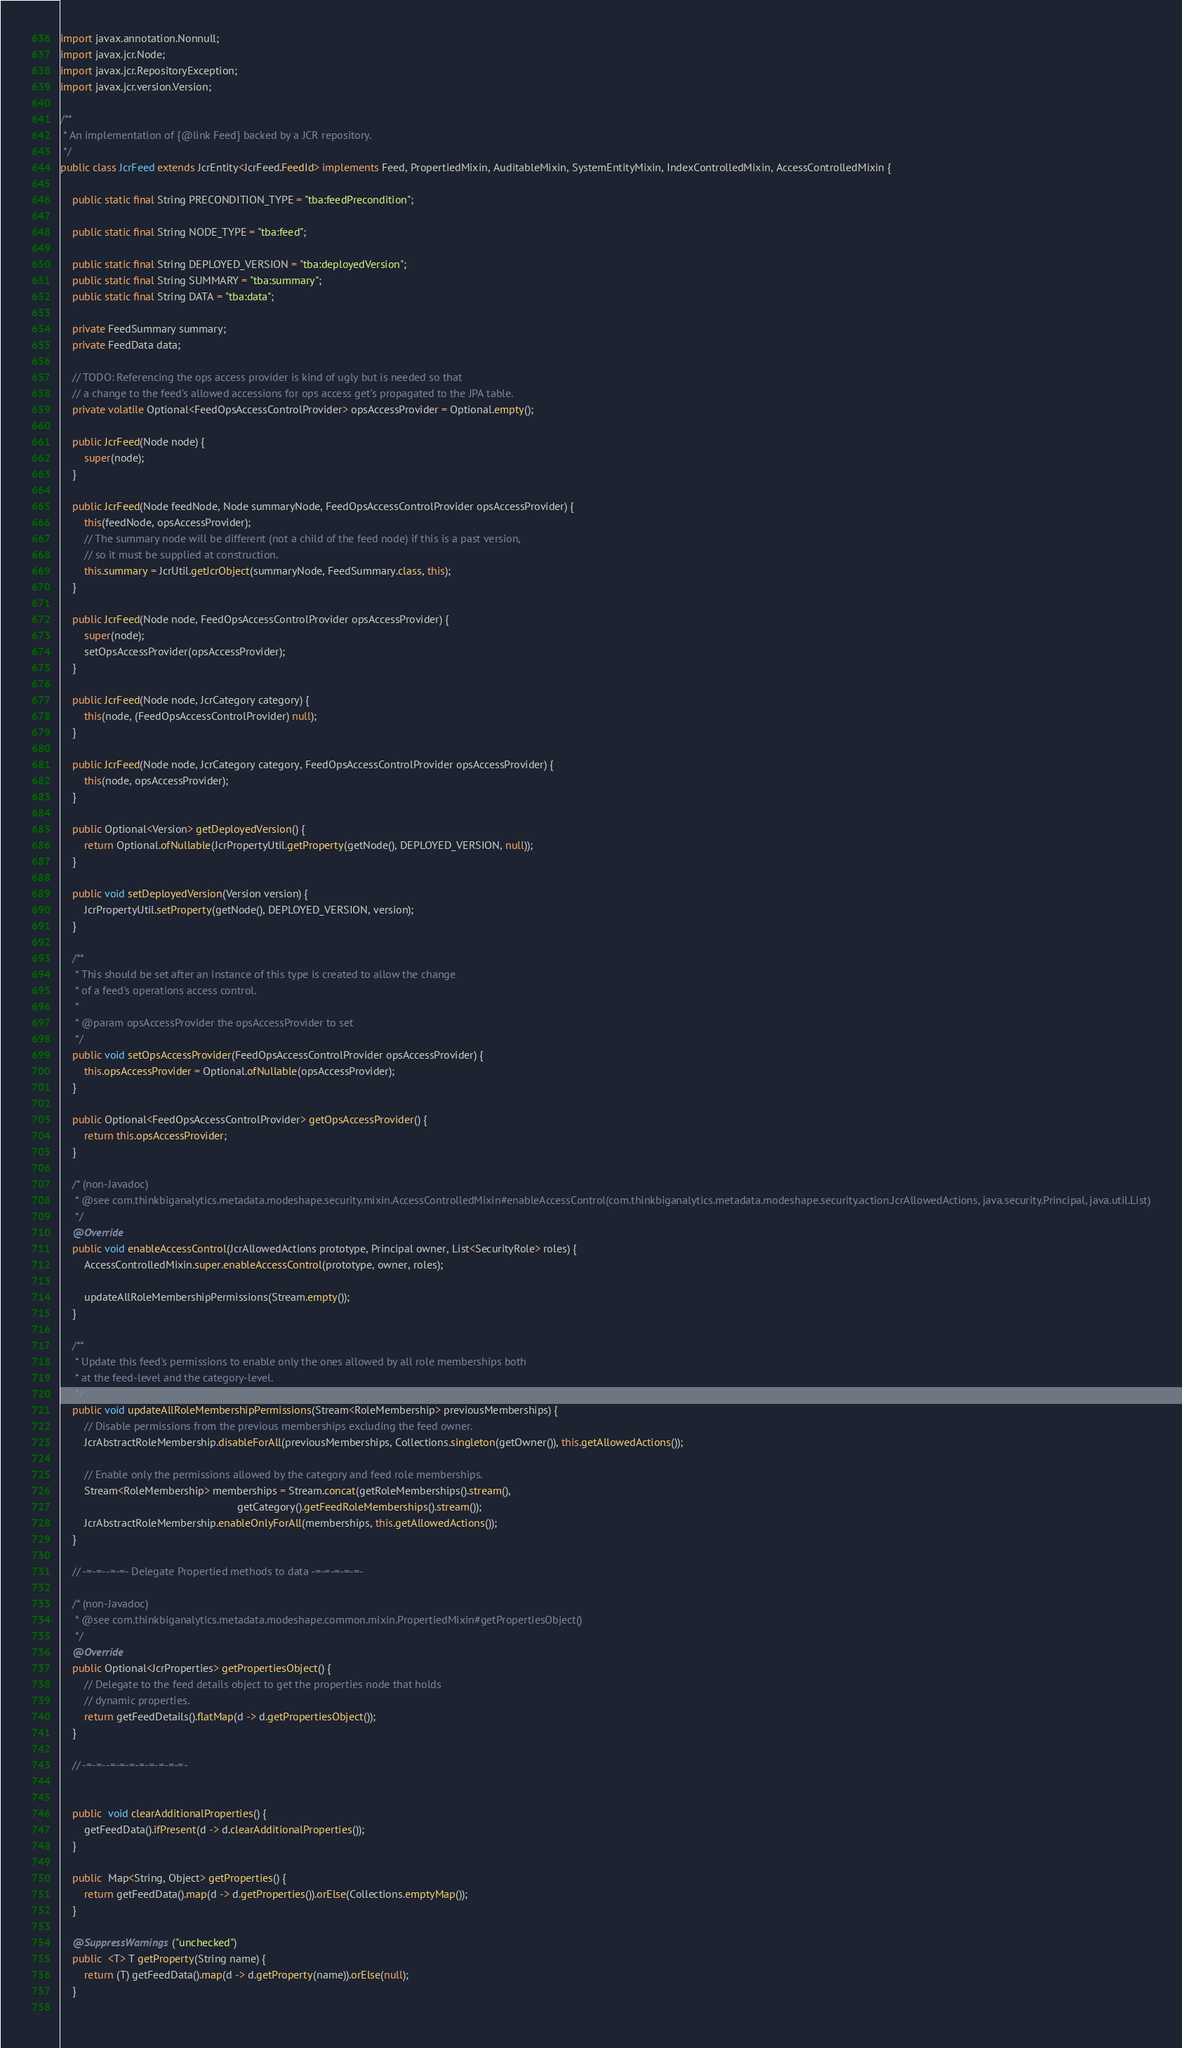<code> <loc_0><loc_0><loc_500><loc_500><_Java_>import javax.annotation.Nonnull;
import javax.jcr.Node;
import javax.jcr.RepositoryException;
import javax.jcr.version.Version;

/**
 * An implementation of {@link Feed} backed by a JCR repository.
 */
public class JcrFeed extends JcrEntity<JcrFeed.FeedId> implements Feed, PropertiedMixin, AuditableMixin, SystemEntityMixin, IndexControlledMixin, AccessControlledMixin {

    public static final String PRECONDITION_TYPE = "tba:feedPrecondition";

    public static final String NODE_TYPE = "tba:feed";

    public static final String DEPLOYED_VERSION = "tba:deployedVersion";
    public static final String SUMMARY = "tba:summary";
    public static final String DATA = "tba:data";

    private FeedSummary summary;
    private FeedData data;

    // TODO: Referencing the ops access provider is kind of ugly but is needed so that 
    // a change to the feed's allowed accessions for ops access get's propagated to the JPA table.
    private volatile Optional<FeedOpsAccessControlProvider> opsAccessProvider = Optional.empty();

    public JcrFeed(Node node) {
        super(node);
    }
    
    public JcrFeed(Node feedNode, Node summaryNode, FeedOpsAccessControlProvider opsAccessProvider) {
        this(feedNode, opsAccessProvider);
        // The summary node will be different (not a child of the feed node) if this is a past version,
        // so it must be supplied at construction.
        this.summary = JcrUtil.getJcrObject(summaryNode, FeedSummary.class, this);
    }

    public JcrFeed(Node node, FeedOpsAccessControlProvider opsAccessProvider) {
        super(node);
        setOpsAccessProvider(opsAccessProvider);
    }

    public JcrFeed(Node node, JcrCategory category) {
        this(node, (FeedOpsAccessControlProvider) null);
    }

    public JcrFeed(Node node, JcrCategory category, FeedOpsAccessControlProvider opsAccessProvider) {
        this(node, opsAccessProvider);
    }
    
    public Optional<Version> getDeployedVersion() {
        return Optional.ofNullable(JcrPropertyUtil.getProperty(getNode(), DEPLOYED_VERSION, null));
    }
    
    public void setDeployedVersion(Version version) {
        JcrPropertyUtil.setProperty(getNode(), DEPLOYED_VERSION, version);
    }
    
    /**
     * This should be set after an instance of this type is created to allow the change
     * of a feed's operations access control.
     *
     * @param opsAccessProvider the opsAccessProvider to set
     */
    public void setOpsAccessProvider(FeedOpsAccessControlProvider opsAccessProvider) {
        this.opsAccessProvider = Optional.ofNullable(opsAccessProvider);
    }

    public Optional<FeedOpsAccessControlProvider> getOpsAccessProvider() {
        return this.opsAccessProvider;
    }
    
    /* (non-Javadoc)
     * @see com.thinkbiganalytics.metadata.modeshape.security.mixin.AccessControlledMixin#enableAccessControl(com.thinkbiganalytics.metadata.modeshape.security.action.JcrAllowedActions, java.security.Principal, java.util.List)
     */
    @Override
    public void enableAccessControl(JcrAllowedActions prototype, Principal owner, List<SecurityRole> roles) {
        AccessControlledMixin.super.enableAccessControl(prototype, owner, roles);
        
        updateAllRoleMembershipPermissions(Stream.empty());
    }
    
    /**
     * Update this feed's permissions to enable only the ones allowed by all role memberships both
     * at the feed-level and the category-level.
     */
    public void updateAllRoleMembershipPermissions(Stream<RoleMembership> previousMemberships) {
        // Disable permissions from the previous memberships excluding the feed owner.
        JcrAbstractRoleMembership.disableForAll(previousMemberships, Collections.singleton(getOwner()), this.getAllowedActions());
        
        // Enable only the permissions allowed by the category and feed role memberships.
        Stream<RoleMembership> memberships = Stream.concat(getRoleMemberships().stream(), 
                                                           getCategory().getFeedRoleMemberships().stream());
        JcrAbstractRoleMembership.enableOnlyForAll(memberships, this.getAllowedActions());
    }

    // -=-=--=-=- Delegate Propertied methods to data -=-=-=-=-=-
    
    /* (non-Javadoc)
     * @see com.thinkbiganalytics.metadata.modeshape.common.mixin.PropertiedMixin#getPropertiesObject()
     */
    @Override
    public Optional<JcrProperties> getPropertiesObject() {
        // Delegate to the feed details object to get the properties node that holds 
        // dynamic properties.
        return getFeedDetails().flatMap(d -> d.getPropertiesObject());
    }
    
    // -=-=--=-=-=-=-=-=-=-=-

    
    public  void clearAdditionalProperties() {
        getFeedData().ifPresent(d -> d.clearAdditionalProperties());
    }
    
    public  Map<String, Object> getProperties() {
        return getFeedData().map(d -> d.getProperties()).orElse(Collections.emptyMap());
    }
    
    @SuppressWarnings("unchecked")
    public  <T> T getProperty(String name) {
        return (T) getFeedData().map(d -> d.getProperty(name)).orElse(null);
    }
    </code> 